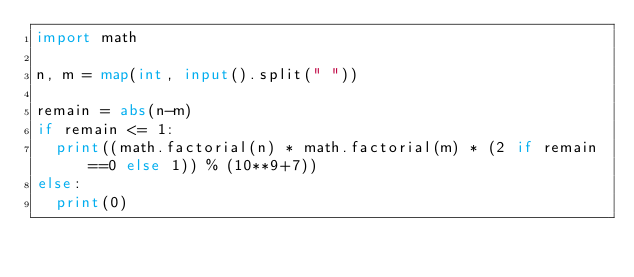<code> <loc_0><loc_0><loc_500><loc_500><_Python_>import math

n, m = map(int, input().split(" "))

remain = abs(n-m)
if remain <= 1:
	print((math.factorial(n) * math.factorial(m) * (2 if remain==0 else 1)) % (10**9+7))
else:
	print(0)
</code> 